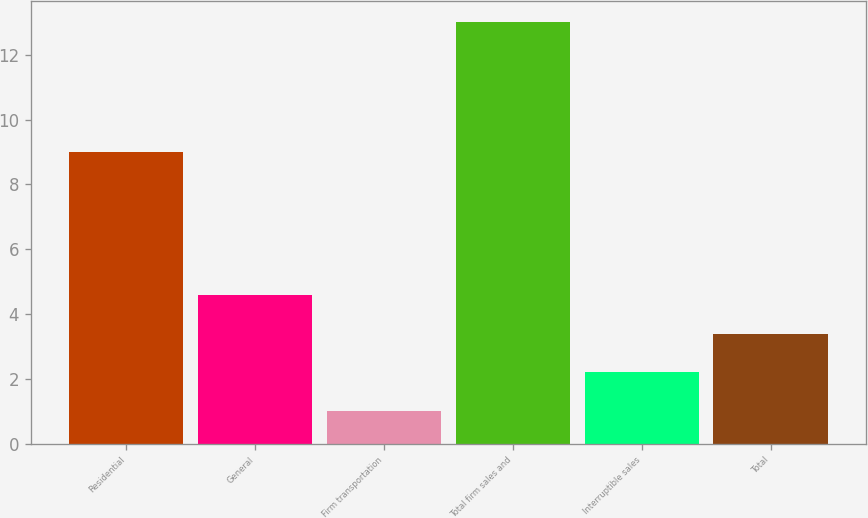<chart> <loc_0><loc_0><loc_500><loc_500><bar_chart><fcel>Residential<fcel>General<fcel>Firm transportation<fcel>Total firm sales and<fcel>Interruptible sales<fcel>Total<nl><fcel>9<fcel>4.6<fcel>1<fcel>13<fcel>2.2<fcel>3.4<nl></chart> 